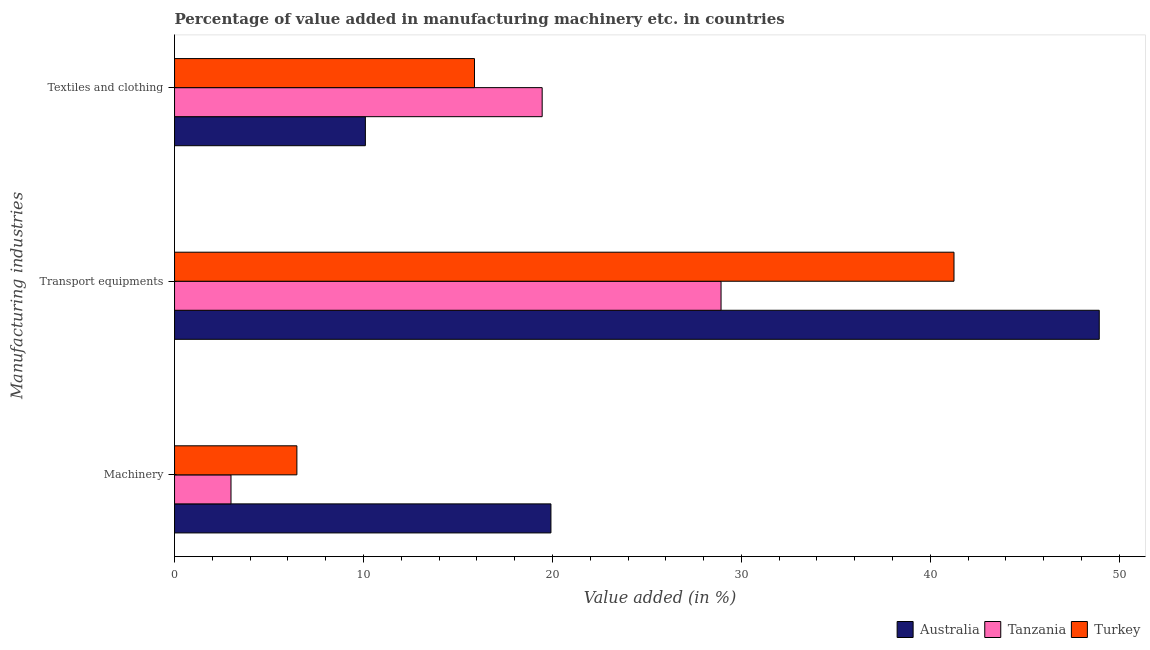Are the number of bars per tick equal to the number of legend labels?
Ensure brevity in your answer.  Yes. How many bars are there on the 1st tick from the bottom?
Make the answer very short. 3. What is the label of the 1st group of bars from the top?
Make the answer very short. Textiles and clothing. What is the value added in manufacturing machinery in Turkey?
Your answer should be very brief. 6.48. Across all countries, what is the maximum value added in manufacturing transport equipments?
Make the answer very short. 48.94. Across all countries, what is the minimum value added in manufacturing machinery?
Provide a short and direct response. 2.99. In which country was the value added in manufacturing textile and clothing maximum?
Provide a succinct answer. Tanzania. In which country was the value added in manufacturing textile and clothing minimum?
Give a very brief answer. Australia. What is the total value added in manufacturing textile and clothing in the graph?
Your answer should be very brief. 45.43. What is the difference between the value added in manufacturing transport equipments in Tanzania and that in Turkey?
Offer a terse response. -12.33. What is the difference between the value added in manufacturing transport equipments in Australia and the value added in manufacturing textile and clothing in Tanzania?
Provide a short and direct response. 29.48. What is the average value added in manufacturing machinery per country?
Give a very brief answer. 9.79. What is the difference between the value added in manufacturing transport equipments and value added in manufacturing machinery in Tanzania?
Your answer should be very brief. 25.94. What is the ratio of the value added in manufacturing machinery in Tanzania to that in Australia?
Offer a terse response. 0.15. Is the value added in manufacturing textile and clothing in Tanzania less than that in Turkey?
Keep it short and to the point. No. Is the difference between the value added in manufacturing transport equipments in Australia and Tanzania greater than the difference between the value added in manufacturing machinery in Australia and Tanzania?
Your response must be concise. Yes. What is the difference between the highest and the second highest value added in manufacturing transport equipments?
Provide a short and direct response. 7.69. What is the difference between the highest and the lowest value added in manufacturing textile and clothing?
Your response must be concise. 9.36. In how many countries, is the value added in manufacturing machinery greater than the average value added in manufacturing machinery taken over all countries?
Ensure brevity in your answer.  1. Is the sum of the value added in manufacturing transport equipments in Tanzania and Turkey greater than the maximum value added in manufacturing machinery across all countries?
Offer a very short reply. Yes. What does the 2nd bar from the bottom in Machinery represents?
Offer a terse response. Tanzania. How many bars are there?
Offer a terse response. 9. What is the difference between two consecutive major ticks on the X-axis?
Offer a very short reply. 10. Are the values on the major ticks of X-axis written in scientific E-notation?
Make the answer very short. No. Does the graph contain any zero values?
Provide a short and direct response. No. Does the graph contain grids?
Your answer should be compact. No. How many legend labels are there?
Your response must be concise. 3. How are the legend labels stacked?
Your answer should be compact. Horizontal. What is the title of the graph?
Provide a succinct answer. Percentage of value added in manufacturing machinery etc. in countries. What is the label or title of the X-axis?
Your response must be concise. Value added (in %). What is the label or title of the Y-axis?
Keep it short and to the point. Manufacturing industries. What is the Value added (in %) in Australia in Machinery?
Ensure brevity in your answer.  19.92. What is the Value added (in %) of Tanzania in Machinery?
Make the answer very short. 2.99. What is the Value added (in %) of Turkey in Machinery?
Provide a short and direct response. 6.48. What is the Value added (in %) of Australia in Transport equipments?
Keep it short and to the point. 48.94. What is the Value added (in %) of Tanzania in Transport equipments?
Give a very brief answer. 28.92. What is the Value added (in %) of Turkey in Transport equipments?
Make the answer very short. 41.25. What is the Value added (in %) in Australia in Textiles and clothing?
Offer a very short reply. 10.1. What is the Value added (in %) in Tanzania in Textiles and clothing?
Ensure brevity in your answer.  19.46. What is the Value added (in %) in Turkey in Textiles and clothing?
Offer a very short reply. 15.87. Across all Manufacturing industries, what is the maximum Value added (in %) in Australia?
Give a very brief answer. 48.94. Across all Manufacturing industries, what is the maximum Value added (in %) of Tanzania?
Provide a succinct answer. 28.92. Across all Manufacturing industries, what is the maximum Value added (in %) of Turkey?
Offer a very short reply. 41.25. Across all Manufacturing industries, what is the minimum Value added (in %) of Australia?
Ensure brevity in your answer.  10.1. Across all Manufacturing industries, what is the minimum Value added (in %) in Tanzania?
Keep it short and to the point. 2.99. Across all Manufacturing industries, what is the minimum Value added (in %) of Turkey?
Keep it short and to the point. 6.48. What is the total Value added (in %) of Australia in the graph?
Your response must be concise. 78.96. What is the total Value added (in %) of Tanzania in the graph?
Offer a terse response. 51.37. What is the total Value added (in %) of Turkey in the graph?
Provide a short and direct response. 63.6. What is the difference between the Value added (in %) in Australia in Machinery and that in Transport equipments?
Ensure brevity in your answer.  -29.02. What is the difference between the Value added (in %) of Tanzania in Machinery and that in Transport equipments?
Ensure brevity in your answer.  -25.94. What is the difference between the Value added (in %) in Turkey in Machinery and that in Transport equipments?
Ensure brevity in your answer.  -34.78. What is the difference between the Value added (in %) in Australia in Machinery and that in Textiles and clothing?
Your response must be concise. 9.82. What is the difference between the Value added (in %) in Tanzania in Machinery and that in Textiles and clothing?
Keep it short and to the point. -16.47. What is the difference between the Value added (in %) of Turkey in Machinery and that in Textiles and clothing?
Provide a succinct answer. -9.4. What is the difference between the Value added (in %) in Australia in Transport equipments and that in Textiles and clothing?
Offer a very short reply. 38.84. What is the difference between the Value added (in %) in Tanzania in Transport equipments and that in Textiles and clothing?
Give a very brief answer. 9.47. What is the difference between the Value added (in %) in Turkey in Transport equipments and that in Textiles and clothing?
Ensure brevity in your answer.  25.38. What is the difference between the Value added (in %) of Australia in Machinery and the Value added (in %) of Tanzania in Transport equipments?
Keep it short and to the point. -9. What is the difference between the Value added (in %) of Australia in Machinery and the Value added (in %) of Turkey in Transport equipments?
Offer a terse response. -21.33. What is the difference between the Value added (in %) in Tanzania in Machinery and the Value added (in %) in Turkey in Transport equipments?
Provide a short and direct response. -38.27. What is the difference between the Value added (in %) in Australia in Machinery and the Value added (in %) in Tanzania in Textiles and clothing?
Your response must be concise. 0.46. What is the difference between the Value added (in %) in Australia in Machinery and the Value added (in %) in Turkey in Textiles and clothing?
Your answer should be compact. 4.05. What is the difference between the Value added (in %) in Tanzania in Machinery and the Value added (in %) in Turkey in Textiles and clothing?
Offer a terse response. -12.89. What is the difference between the Value added (in %) in Australia in Transport equipments and the Value added (in %) in Tanzania in Textiles and clothing?
Give a very brief answer. 29.48. What is the difference between the Value added (in %) in Australia in Transport equipments and the Value added (in %) in Turkey in Textiles and clothing?
Your answer should be compact. 33.07. What is the difference between the Value added (in %) of Tanzania in Transport equipments and the Value added (in %) of Turkey in Textiles and clothing?
Your answer should be very brief. 13.05. What is the average Value added (in %) in Australia per Manufacturing industries?
Your answer should be compact. 26.32. What is the average Value added (in %) of Tanzania per Manufacturing industries?
Keep it short and to the point. 17.12. What is the average Value added (in %) in Turkey per Manufacturing industries?
Your response must be concise. 21.2. What is the difference between the Value added (in %) of Australia and Value added (in %) of Tanzania in Machinery?
Offer a very short reply. 16.93. What is the difference between the Value added (in %) in Australia and Value added (in %) in Turkey in Machinery?
Offer a terse response. 13.45. What is the difference between the Value added (in %) of Tanzania and Value added (in %) of Turkey in Machinery?
Give a very brief answer. -3.49. What is the difference between the Value added (in %) in Australia and Value added (in %) in Tanzania in Transport equipments?
Give a very brief answer. 20.02. What is the difference between the Value added (in %) of Australia and Value added (in %) of Turkey in Transport equipments?
Your answer should be compact. 7.69. What is the difference between the Value added (in %) of Tanzania and Value added (in %) of Turkey in Transport equipments?
Your response must be concise. -12.33. What is the difference between the Value added (in %) of Australia and Value added (in %) of Tanzania in Textiles and clothing?
Your answer should be compact. -9.36. What is the difference between the Value added (in %) in Australia and Value added (in %) in Turkey in Textiles and clothing?
Provide a short and direct response. -5.77. What is the difference between the Value added (in %) of Tanzania and Value added (in %) of Turkey in Textiles and clothing?
Provide a succinct answer. 3.58. What is the ratio of the Value added (in %) in Australia in Machinery to that in Transport equipments?
Offer a very short reply. 0.41. What is the ratio of the Value added (in %) of Tanzania in Machinery to that in Transport equipments?
Ensure brevity in your answer.  0.1. What is the ratio of the Value added (in %) in Turkey in Machinery to that in Transport equipments?
Give a very brief answer. 0.16. What is the ratio of the Value added (in %) of Australia in Machinery to that in Textiles and clothing?
Offer a terse response. 1.97. What is the ratio of the Value added (in %) of Tanzania in Machinery to that in Textiles and clothing?
Ensure brevity in your answer.  0.15. What is the ratio of the Value added (in %) in Turkey in Machinery to that in Textiles and clothing?
Your answer should be very brief. 0.41. What is the ratio of the Value added (in %) in Australia in Transport equipments to that in Textiles and clothing?
Make the answer very short. 4.85. What is the ratio of the Value added (in %) in Tanzania in Transport equipments to that in Textiles and clothing?
Offer a terse response. 1.49. What is the ratio of the Value added (in %) in Turkey in Transport equipments to that in Textiles and clothing?
Your answer should be compact. 2.6. What is the difference between the highest and the second highest Value added (in %) in Australia?
Your answer should be very brief. 29.02. What is the difference between the highest and the second highest Value added (in %) of Tanzania?
Offer a terse response. 9.47. What is the difference between the highest and the second highest Value added (in %) of Turkey?
Offer a very short reply. 25.38. What is the difference between the highest and the lowest Value added (in %) in Australia?
Provide a short and direct response. 38.84. What is the difference between the highest and the lowest Value added (in %) of Tanzania?
Provide a succinct answer. 25.94. What is the difference between the highest and the lowest Value added (in %) in Turkey?
Provide a short and direct response. 34.78. 